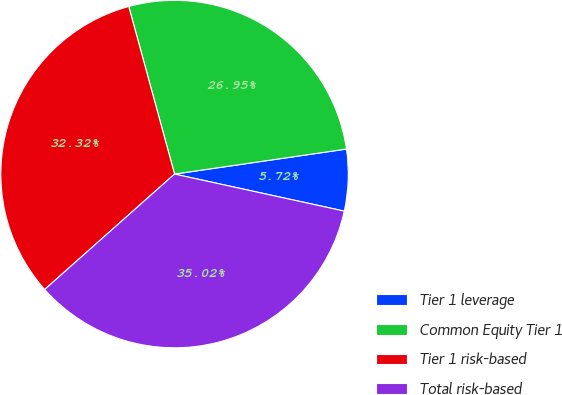Convert chart. <chart><loc_0><loc_0><loc_500><loc_500><pie_chart><fcel>Tier 1 leverage<fcel>Common Equity Tier 1<fcel>Tier 1 risk-based<fcel>Total risk-based<nl><fcel>5.72%<fcel>26.95%<fcel>32.32%<fcel>35.02%<nl></chart> 